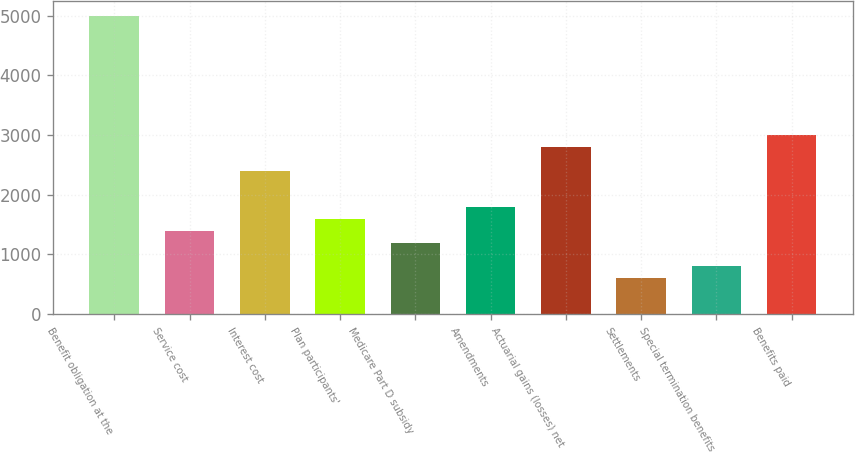<chart> <loc_0><loc_0><loc_500><loc_500><bar_chart><fcel>Benefit obligation at the<fcel>Service cost<fcel>Interest cost<fcel>Plan participants'<fcel>Medicare Part D subsidy<fcel>Amendments<fcel>Actuarial gains (losses) net<fcel>Settlements<fcel>Special termination benefits<fcel>Benefits paid<nl><fcel>4988.5<fcel>1397.5<fcel>2395<fcel>1597<fcel>1198<fcel>1796.5<fcel>2794<fcel>599.5<fcel>799<fcel>2993.5<nl></chart> 